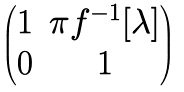<formula> <loc_0><loc_0><loc_500><loc_500>\begin{pmatrix} 1 & \pi f ^ { - 1 } [ \lambda ] \\ 0 & 1 \end{pmatrix}</formula> 